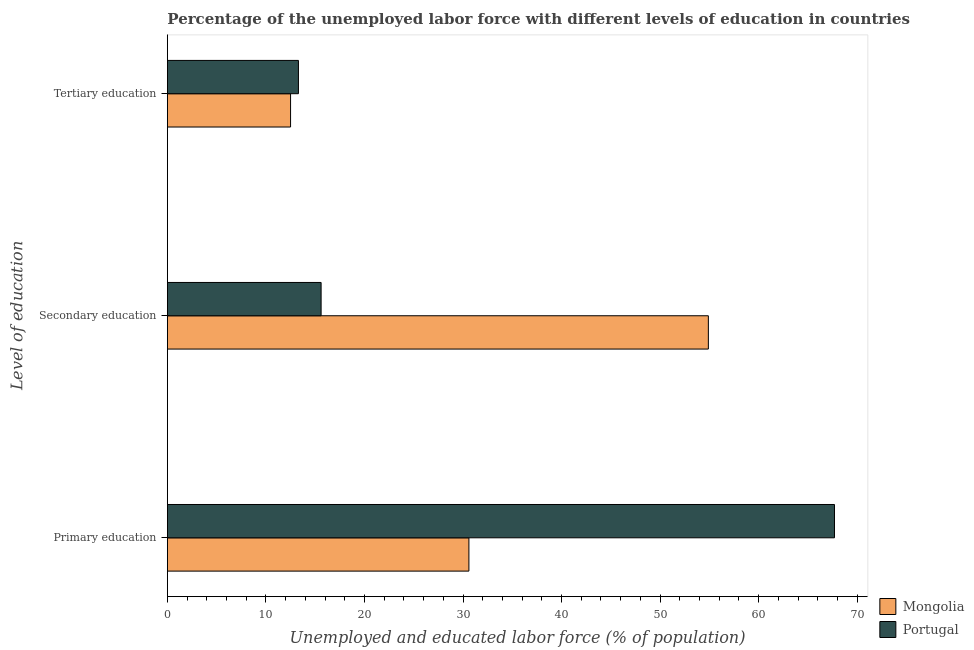How many groups of bars are there?
Provide a short and direct response. 3. Are the number of bars on each tick of the Y-axis equal?
Give a very brief answer. Yes. How many bars are there on the 2nd tick from the top?
Ensure brevity in your answer.  2. What is the label of the 2nd group of bars from the top?
Provide a short and direct response. Secondary education. What is the percentage of labor force who received tertiary education in Mongolia?
Your answer should be very brief. 12.5. Across all countries, what is the maximum percentage of labor force who received secondary education?
Your answer should be very brief. 54.9. Across all countries, what is the minimum percentage of labor force who received secondary education?
Your response must be concise. 15.6. In which country was the percentage of labor force who received secondary education maximum?
Your response must be concise. Mongolia. What is the total percentage of labor force who received secondary education in the graph?
Ensure brevity in your answer.  70.5. What is the difference between the percentage of labor force who received primary education in Mongolia and that in Portugal?
Make the answer very short. -37.1. What is the difference between the percentage of labor force who received tertiary education in Mongolia and the percentage of labor force who received secondary education in Portugal?
Provide a succinct answer. -3.1. What is the average percentage of labor force who received tertiary education per country?
Make the answer very short. 12.9. What is the difference between the percentage of labor force who received primary education and percentage of labor force who received tertiary education in Mongolia?
Offer a very short reply. 18.1. What is the ratio of the percentage of labor force who received primary education in Mongolia to that in Portugal?
Provide a short and direct response. 0.45. Is the difference between the percentage of labor force who received secondary education in Mongolia and Portugal greater than the difference between the percentage of labor force who received primary education in Mongolia and Portugal?
Your answer should be compact. Yes. What is the difference between the highest and the second highest percentage of labor force who received secondary education?
Your answer should be very brief. 39.3. What is the difference between the highest and the lowest percentage of labor force who received primary education?
Provide a short and direct response. 37.1. Is the sum of the percentage of labor force who received secondary education in Portugal and Mongolia greater than the maximum percentage of labor force who received primary education across all countries?
Provide a short and direct response. Yes. What does the 2nd bar from the top in Primary education represents?
Offer a terse response. Mongolia. What does the 2nd bar from the bottom in Tertiary education represents?
Offer a very short reply. Portugal. Are all the bars in the graph horizontal?
Your answer should be compact. Yes. How many countries are there in the graph?
Provide a short and direct response. 2. What is the difference between two consecutive major ticks on the X-axis?
Your answer should be compact. 10. Are the values on the major ticks of X-axis written in scientific E-notation?
Your answer should be very brief. No. Does the graph contain any zero values?
Give a very brief answer. No. How are the legend labels stacked?
Your response must be concise. Vertical. What is the title of the graph?
Ensure brevity in your answer.  Percentage of the unemployed labor force with different levels of education in countries. Does "Cambodia" appear as one of the legend labels in the graph?
Keep it short and to the point. No. What is the label or title of the X-axis?
Your answer should be compact. Unemployed and educated labor force (% of population). What is the label or title of the Y-axis?
Offer a terse response. Level of education. What is the Unemployed and educated labor force (% of population) of Mongolia in Primary education?
Offer a terse response. 30.6. What is the Unemployed and educated labor force (% of population) of Portugal in Primary education?
Your answer should be compact. 67.7. What is the Unemployed and educated labor force (% of population) of Mongolia in Secondary education?
Offer a very short reply. 54.9. What is the Unemployed and educated labor force (% of population) of Portugal in Secondary education?
Your answer should be compact. 15.6. What is the Unemployed and educated labor force (% of population) of Portugal in Tertiary education?
Make the answer very short. 13.3. Across all Level of education, what is the maximum Unemployed and educated labor force (% of population) in Mongolia?
Offer a terse response. 54.9. Across all Level of education, what is the maximum Unemployed and educated labor force (% of population) of Portugal?
Your answer should be compact. 67.7. Across all Level of education, what is the minimum Unemployed and educated labor force (% of population) in Mongolia?
Your response must be concise. 12.5. Across all Level of education, what is the minimum Unemployed and educated labor force (% of population) of Portugal?
Provide a succinct answer. 13.3. What is the total Unemployed and educated labor force (% of population) in Mongolia in the graph?
Offer a very short reply. 98. What is the total Unemployed and educated labor force (% of population) in Portugal in the graph?
Give a very brief answer. 96.6. What is the difference between the Unemployed and educated labor force (% of population) in Mongolia in Primary education and that in Secondary education?
Offer a very short reply. -24.3. What is the difference between the Unemployed and educated labor force (% of population) of Portugal in Primary education and that in Secondary education?
Your answer should be very brief. 52.1. What is the difference between the Unemployed and educated labor force (% of population) of Portugal in Primary education and that in Tertiary education?
Your response must be concise. 54.4. What is the difference between the Unemployed and educated labor force (% of population) of Mongolia in Secondary education and that in Tertiary education?
Provide a short and direct response. 42.4. What is the difference between the Unemployed and educated labor force (% of population) in Mongolia in Primary education and the Unemployed and educated labor force (% of population) in Portugal in Secondary education?
Provide a short and direct response. 15. What is the difference between the Unemployed and educated labor force (% of population) of Mongolia in Primary education and the Unemployed and educated labor force (% of population) of Portugal in Tertiary education?
Provide a succinct answer. 17.3. What is the difference between the Unemployed and educated labor force (% of population) in Mongolia in Secondary education and the Unemployed and educated labor force (% of population) in Portugal in Tertiary education?
Offer a very short reply. 41.6. What is the average Unemployed and educated labor force (% of population) of Mongolia per Level of education?
Make the answer very short. 32.67. What is the average Unemployed and educated labor force (% of population) in Portugal per Level of education?
Provide a short and direct response. 32.2. What is the difference between the Unemployed and educated labor force (% of population) in Mongolia and Unemployed and educated labor force (% of population) in Portugal in Primary education?
Your answer should be very brief. -37.1. What is the difference between the Unemployed and educated labor force (% of population) in Mongolia and Unemployed and educated labor force (% of population) in Portugal in Secondary education?
Give a very brief answer. 39.3. What is the difference between the Unemployed and educated labor force (% of population) of Mongolia and Unemployed and educated labor force (% of population) of Portugal in Tertiary education?
Your answer should be very brief. -0.8. What is the ratio of the Unemployed and educated labor force (% of population) of Mongolia in Primary education to that in Secondary education?
Offer a very short reply. 0.56. What is the ratio of the Unemployed and educated labor force (% of population) in Portugal in Primary education to that in Secondary education?
Keep it short and to the point. 4.34. What is the ratio of the Unemployed and educated labor force (% of population) in Mongolia in Primary education to that in Tertiary education?
Your answer should be very brief. 2.45. What is the ratio of the Unemployed and educated labor force (% of population) of Portugal in Primary education to that in Tertiary education?
Provide a succinct answer. 5.09. What is the ratio of the Unemployed and educated labor force (% of population) of Mongolia in Secondary education to that in Tertiary education?
Provide a short and direct response. 4.39. What is the ratio of the Unemployed and educated labor force (% of population) in Portugal in Secondary education to that in Tertiary education?
Offer a very short reply. 1.17. What is the difference between the highest and the second highest Unemployed and educated labor force (% of population) in Mongolia?
Your response must be concise. 24.3. What is the difference between the highest and the second highest Unemployed and educated labor force (% of population) of Portugal?
Provide a succinct answer. 52.1. What is the difference between the highest and the lowest Unemployed and educated labor force (% of population) of Mongolia?
Your response must be concise. 42.4. What is the difference between the highest and the lowest Unemployed and educated labor force (% of population) in Portugal?
Offer a very short reply. 54.4. 